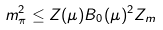<formula> <loc_0><loc_0><loc_500><loc_500>m _ { \pi } ^ { 2 } \leq Z ( \mu ) B _ { 0 } ( \mu ) ^ { 2 } Z _ { m }</formula> 